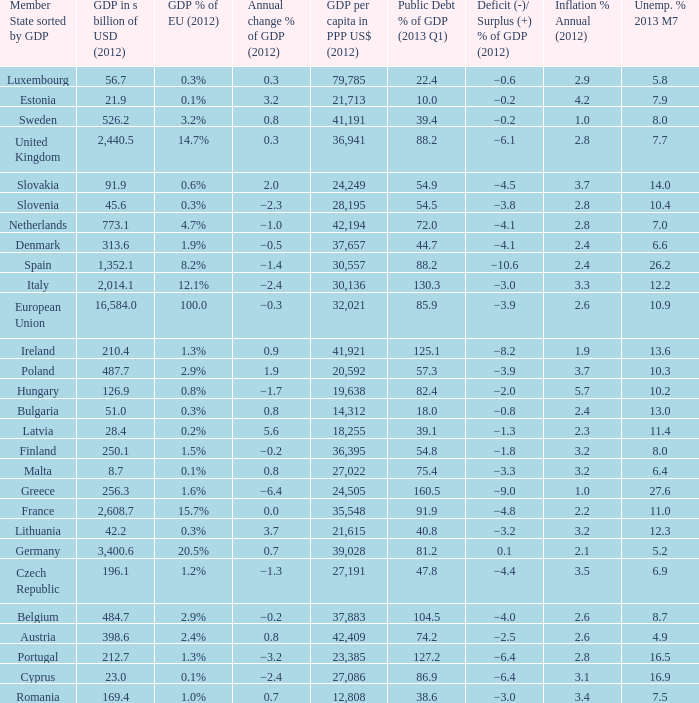What is the largest inflation % annual in 2012 of the country with a public debt % of GDP in 2013 Q1 greater than 88.2 and a GDP % of EU in 2012 of 2.9%? 2.6. 